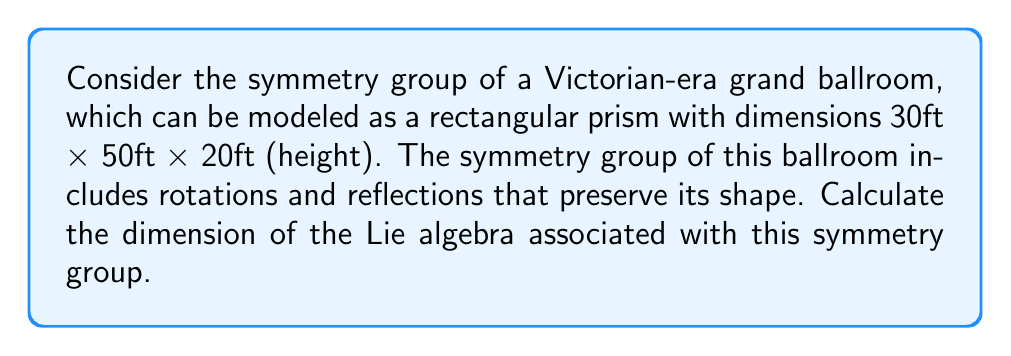Can you answer this question? To solve this problem, we need to follow these steps:

1) First, identify the symmetry group of the ballroom. The symmetry group of a rectangular prism is $D_{2h}$, which is the direct product of three reflection groups: $C_{2h} \times C_{2v} \times C_{2v}$.

2) The order of $D_{2h}$ is 8, as it includes:
   - The identity transformation
   - Three 180° rotations (around x, y, and z axes)
   - Three reflections (in xy, yz, and xz planes)
   - Inversion (point reflection through the center)

3) The Lie group corresponding to $D_{2h}$ is $O(3)$, the group of 3x3 orthogonal matrices.

4) The dimension of the Lie algebra is equal to the dimension of the tangent space at the identity of the Lie group.

5) For $O(3)$, the dimension of the Lie algebra, denoted $\mathfrak{o}(3)$, is given by:

   $$\dim(\mathfrak{o}(3)) = \frac{n(n-1)}{2}$$

   where $n$ is the dimension of the space (in this case, 3).

6) Plugging in $n=3$:

   $$\dim(\mathfrak{o}(3)) = \frac{3(3-1)}{2} = \frac{3 \cdot 2}{2} = 3$$

Thus, the dimension of the Lie algebra associated with the symmetry group of the Victorian ballroom is 3.
Answer: The dimension of the Lie algebra is 3. 